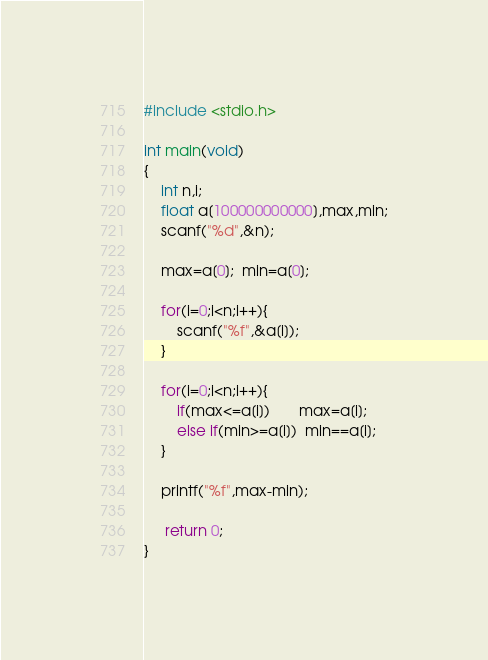Convert code to text. <code><loc_0><loc_0><loc_500><loc_500><_C_>#include <stdio.h>
 
int main(void)
{
    int n,i;
    float a[100000000000],max,min;
    scanf("%d",&n);
  
    max=a[0];  min=a[0];
  
    for(i=0;i<n;i++){
        scanf("%f",&a[i]);
    }
  
    for(i=0;i<n;i++){
        if(max<=a[i])       max=a[i];
        else if(min>=a[i])  min==a[i];
    }
  
    printf("%f",max-min);
  
     return 0;
}  </code> 